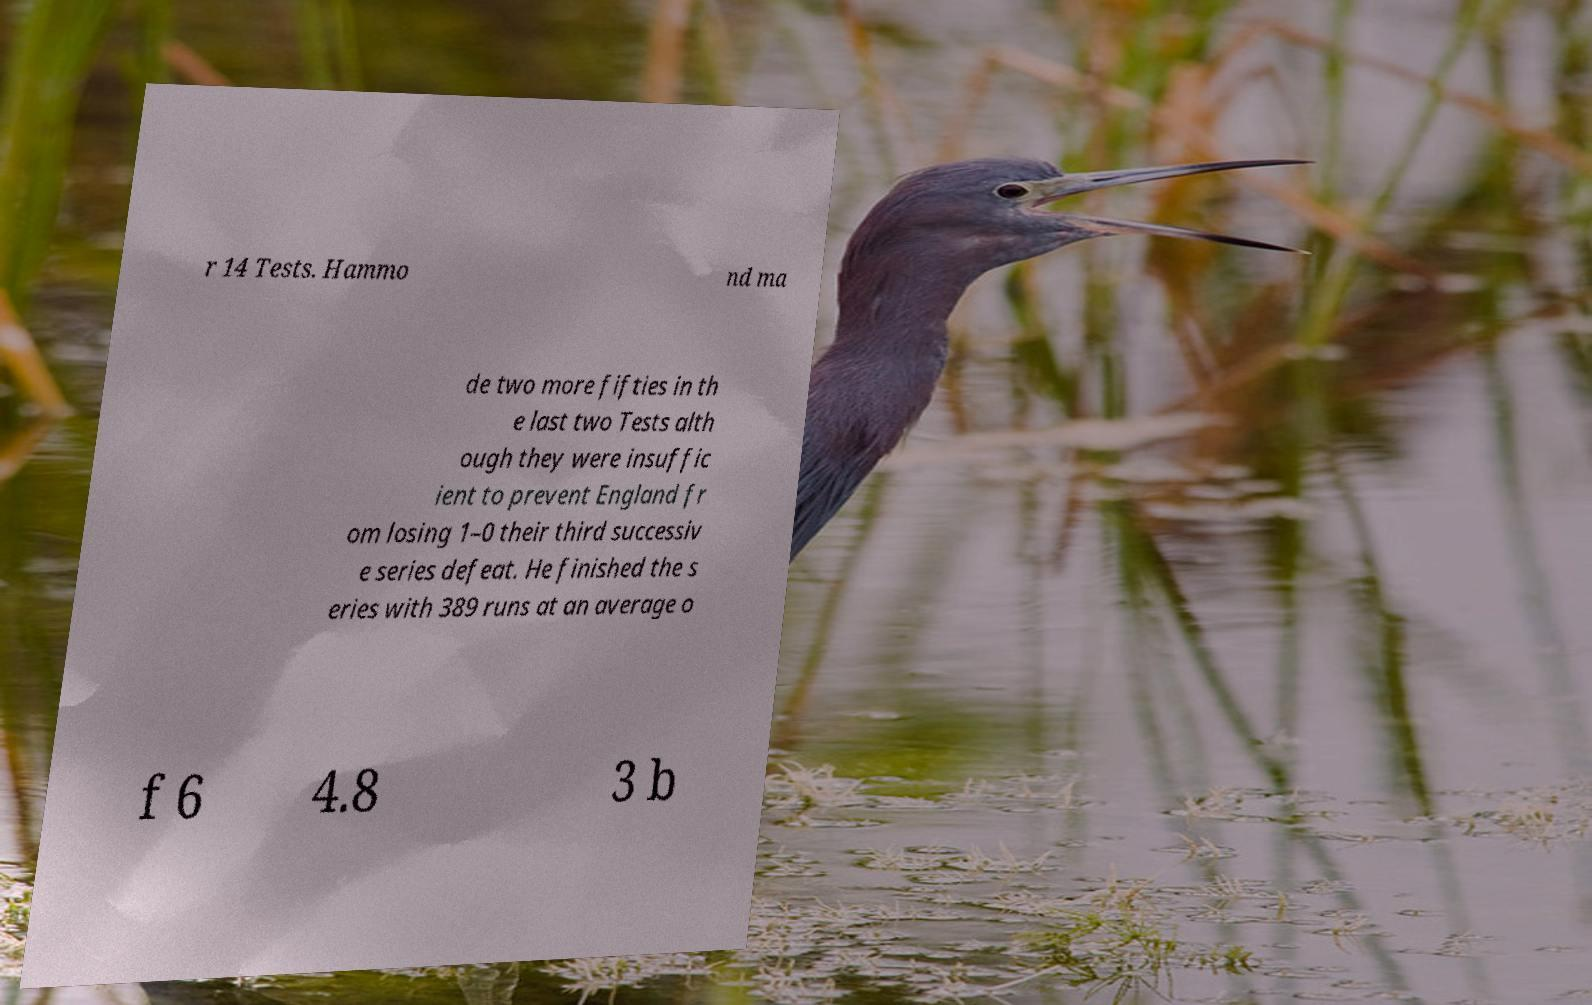I need the written content from this picture converted into text. Can you do that? r 14 Tests. Hammo nd ma de two more fifties in th e last two Tests alth ough they were insuffic ient to prevent England fr om losing 1–0 their third successiv e series defeat. He finished the s eries with 389 runs at an average o f 6 4.8 3 b 